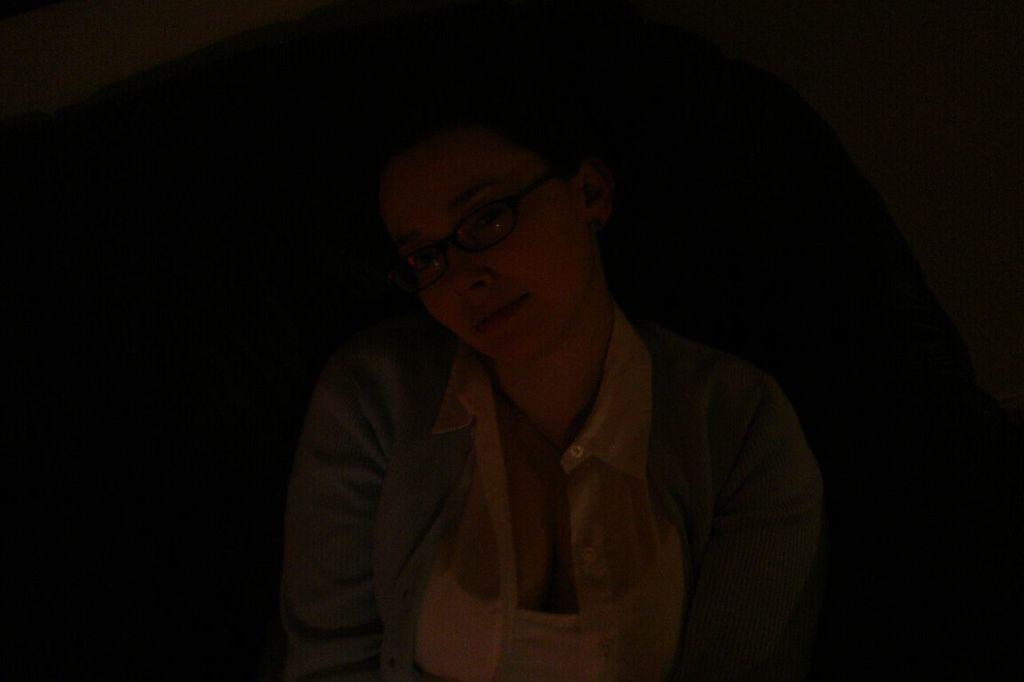Describe this image in one or two sentences. In this image we can see a person. And the given image is dark. 